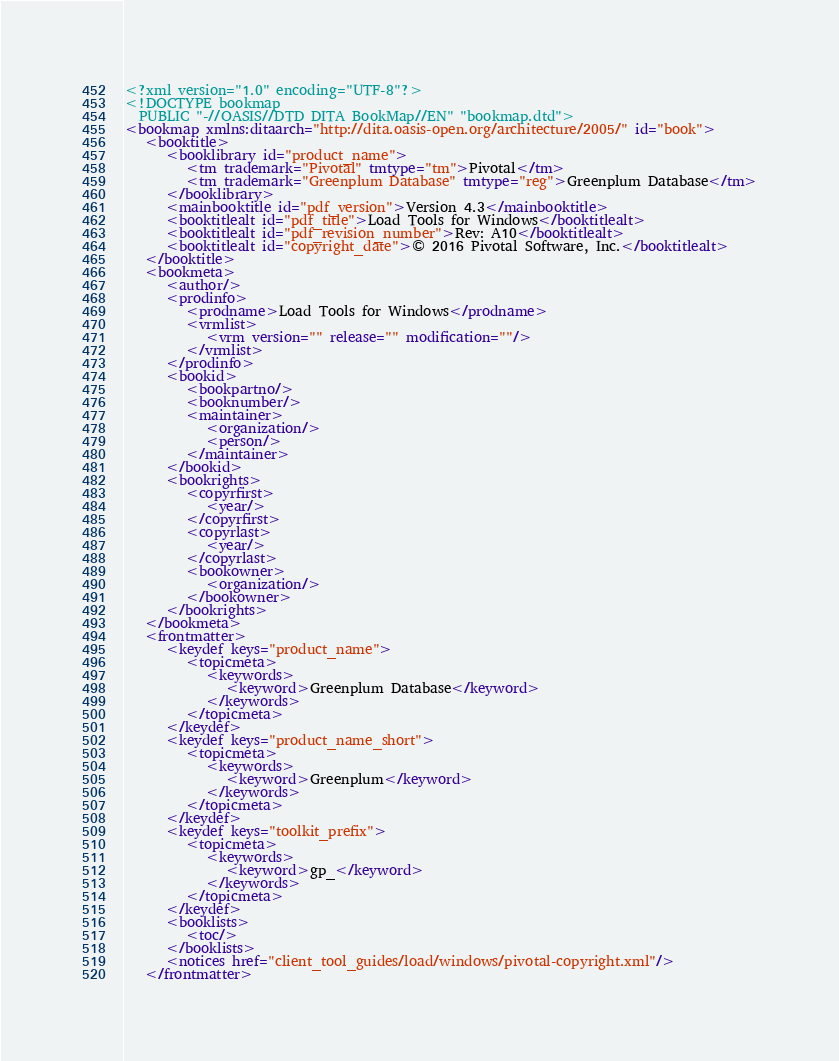<code> <loc_0><loc_0><loc_500><loc_500><_XML_><?xml version="1.0" encoding="UTF-8"?>
<!DOCTYPE bookmap
  PUBLIC "-//OASIS//DTD DITA BookMap//EN" "bookmap.dtd">
<bookmap xmlns:ditaarch="http://dita.oasis-open.org/architecture/2005/" id="book">
   <booktitle>
      <booklibrary id="product_name">
         <tm trademark="Pivotal" tmtype="tm">Pivotal</tm>
         <tm trademark="Greenplum Database" tmtype="reg">Greenplum Database</tm>
      </booklibrary>
      <mainbooktitle id="pdf_version">Version 4.3</mainbooktitle>
      <booktitlealt id="pdf_title">Load Tools for Windows</booktitlealt>
      <booktitlealt id="pdf_revision_number">Rev: A10</booktitlealt>
      <booktitlealt id="copyright_date">© 2016 Pivotal Software, Inc.</booktitlealt>
   </booktitle>
   <bookmeta>
      <author/>
      <prodinfo>
         <prodname>Load Tools for Windows</prodname>
         <vrmlist>
            <vrm version="" release="" modification=""/>
         </vrmlist>
      </prodinfo>
      <bookid>
         <bookpartno/>
         <booknumber/>
         <maintainer>
            <organization/>
            <person/>
         </maintainer>
      </bookid>
      <bookrights>
         <copyrfirst>
            <year/>
         </copyrfirst>
         <copyrlast>
            <year/>
         </copyrlast>
         <bookowner>
            <organization/>
         </bookowner>
      </bookrights>
   </bookmeta>
   <frontmatter>
      <keydef keys="product_name">
         <topicmeta>
            <keywords>
               <keyword>Greenplum Database</keyword>
            </keywords>
         </topicmeta>
      </keydef>
      <keydef keys="product_name_short">
         <topicmeta>
            <keywords>
               <keyword>Greenplum</keyword>
            </keywords>
         </topicmeta>
      </keydef>
      <keydef keys="toolkit_prefix">
         <topicmeta>
            <keywords>
               <keyword>gp_</keyword>
            </keywords>
         </topicmeta>
      </keydef>
      <booklists>
         <toc/>
      </booklists>
      <notices href="client_tool_guides/load/windows/pivotal-copyright.xml"/>
   </frontmatter></code> 